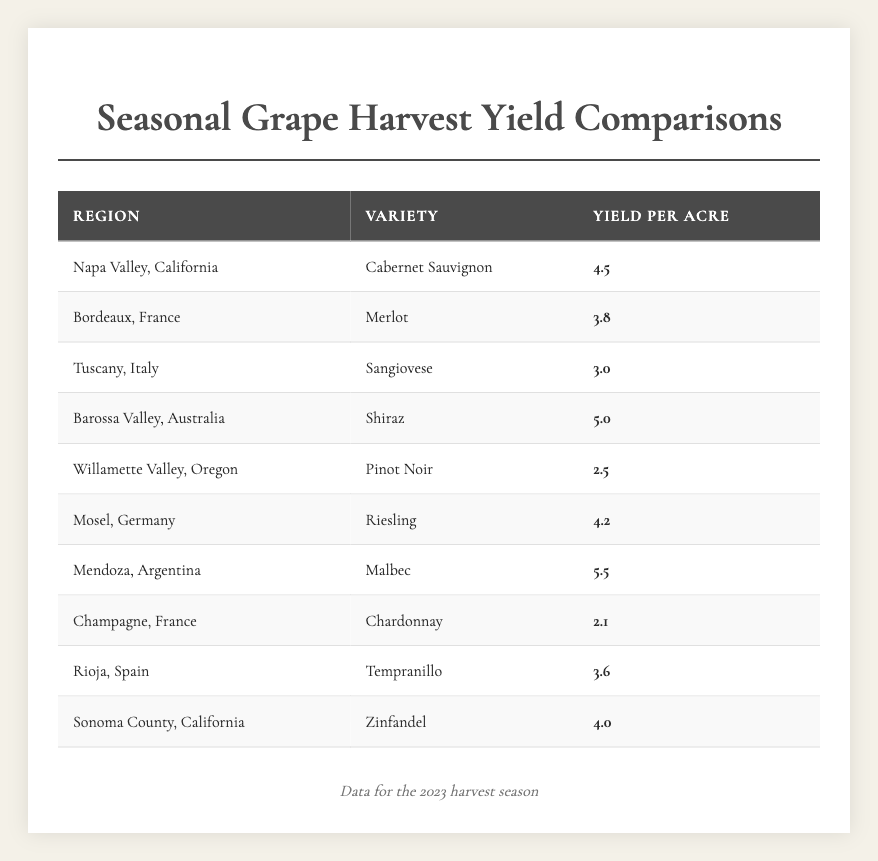What is the highest yield per acre recorded in the table? The table shows yields per acre for various grape varieties and regions. By scanning the values, the highest is 5.5 from Mendoza, Argentina for Malbec.
Answer: 5.5 Which grape variety has the lowest yield per acre in the table? The yields per acre are listed for each grape variety. The lowest yield is 2.1, which corresponds to Chardonnay from Champagne, France.
Answer: 2.1 What is the average yield per acre of Cabernet Sauvignon and Malbec combined? The yields for Cabernet Sauvignon (4.5) and Malbec (5.5) are added together: 4.5 + 5.5 = 10. Then, divide by 2 (the number of varieties) to get the average: 10 / 2 = 5.
Answer: 5.0 In which region does Pinot Noir have its yield, and what is it? The table lists Pinot Noir under Willamette Valley, Oregon with a yield of 2.5 per acre.
Answer: Willamette Valley, Oregon; 2.5 Is the yield of Shiraz greater than the yield of Merlot? The yield of Shiraz is 5.0 per acre and the yield of Merlot is 3.8 per acre. Since 5.0 is greater than 3.8, the answer is yes.
Answer: Yes How many regions have a yield greater than 4.0 per acre? The table lists the following yields greater than 4.0: Napa Valley (4.5), Barossa Valley (5.0), Mendoza (5.5), and Mosel (4.2). There are a total of 4 regions that meet this criterion.
Answer: 4 What is the difference in yield between the highest and lowest varieties listed? The highest yield is 5.5 (Malbec) and the lowest is 2.1 (Chardonnay). The difference is calculated by subtracting: 5.5 - 2.1 = 3.4.
Answer: 3.4 Is there a variety that has a yield of exactly 4.0? Yes, checking through the table, Zinfandel from Sonoma County has a yield of exactly 4.0.
Answer: Yes Which variety has a yield closest to the average of all yields? First, calculate the average yield: (4.5 + 3.8 + 3.0 + 5.0 + 2.5 + 4.2 + 5.5 + 2.1 + 3.6 + 4.0) = 34.2 / 10 = 3.42. The yield of Cabernet Sauvignon (4.5) is closest to this average.
Answer: Cabernet Sauvignon Which two varieties have yields that are within 0.5 of each other? By comparing yields, Riesling (4.2) and Cabernet Sauvignon (4.5) have a difference of only 0.3, which fits within 0.5.
Answer: Riesling and Cabernet Sauvignon 